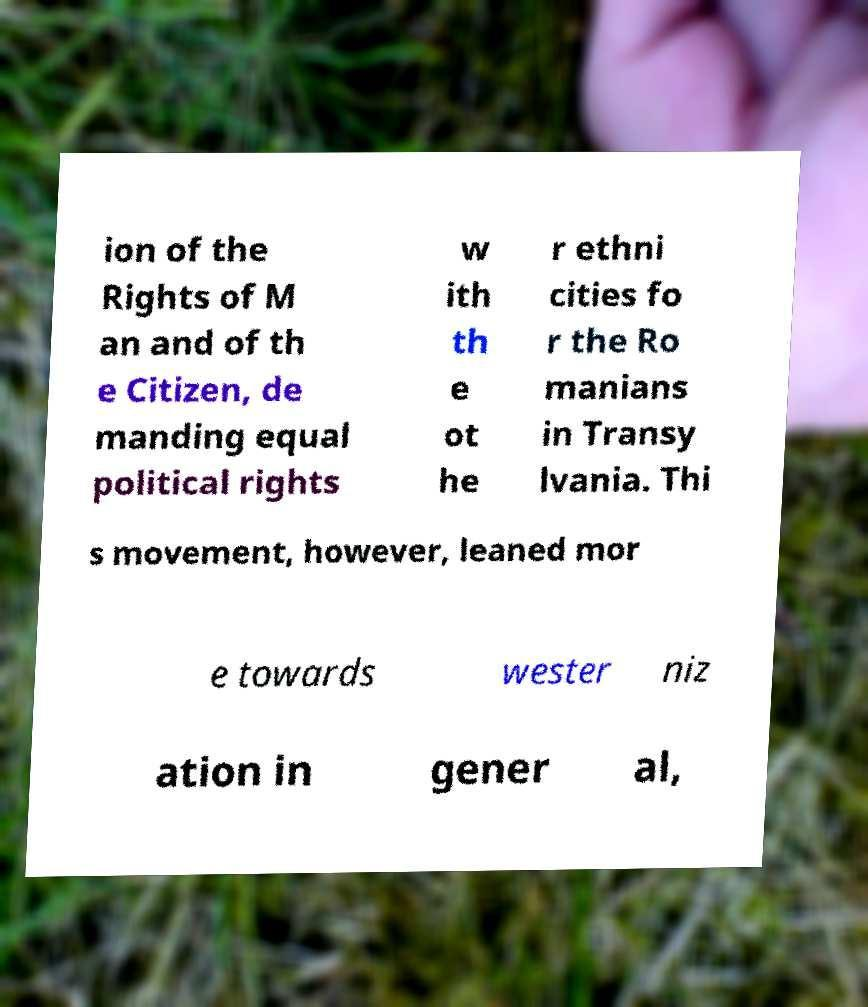Please identify and transcribe the text found in this image. ion of the Rights of M an and of th e Citizen, de manding equal political rights w ith th e ot he r ethni cities fo r the Ro manians in Transy lvania. Thi s movement, however, leaned mor e towards wester niz ation in gener al, 